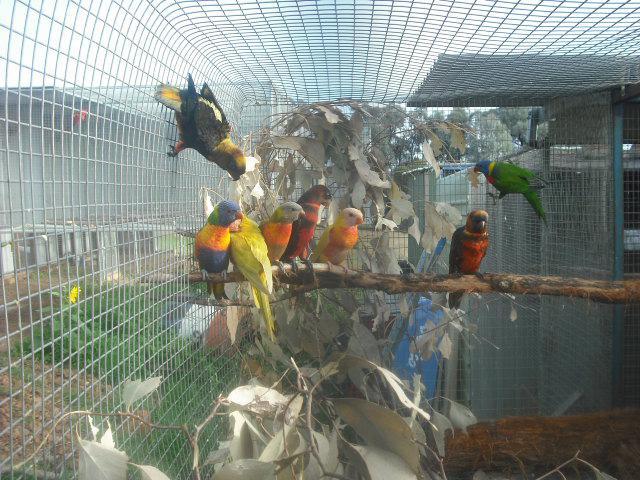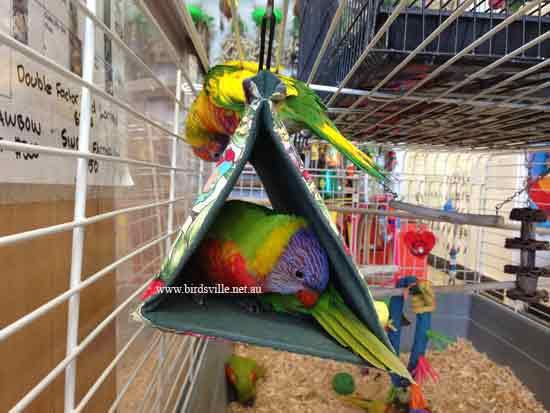The first image is the image on the left, the second image is the image on the right. Evaluate the accuracy of this statement regarding the images: "All of the birds have blue heads and orange/yellow bellies.". Is it true? Answer yes or no. No. The first image is the image on the left, the second image is the image on the right. Evaluate the accuracy of this statement regarding the images: "Each image shows exactly two birds within a cage.". Is it true? Answer yes or no. No. 